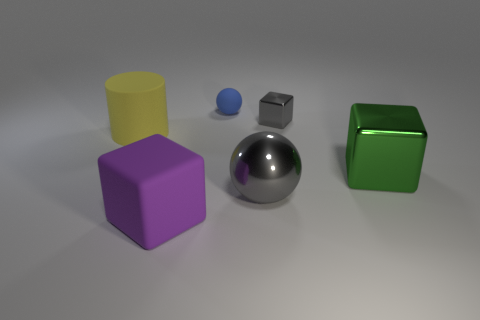Is there any other thing of the same color as the large rubber cube?
Your answer should be compact. No. Does the ball that is on the right side of the small blue matte sphere have the same size as the block in front of the big green object?
Provide a succinct answer. Yes. What number of blue things have the same material as the gray ball?
Make the answer very short. 0. There is a big thing that is right of the ball in front of the blue thing; what number of tiny gray things are on the right side of it?
Provide a succinct answer. 0. Do the small gray shiny thing and the large green metal thing have the same shape?
Offer a very short reply. Yes. Are there any other yellow things of the same shape as the yellow rubber object?
Ensure brevity in your answer.  No. The green object that is the same size as the yellow object is what shape?
Keep it short and to the point. Cube. What material is the ball behind the big rubber thing that is behind the large block left of the large metal block?
Your response must be concise. Rubber. Is the yellow matte cylinder the same size as the blue rubber thing?
Your answer should be compact. No. What is the small block made of?
Provide a short and direct response. Metal. 